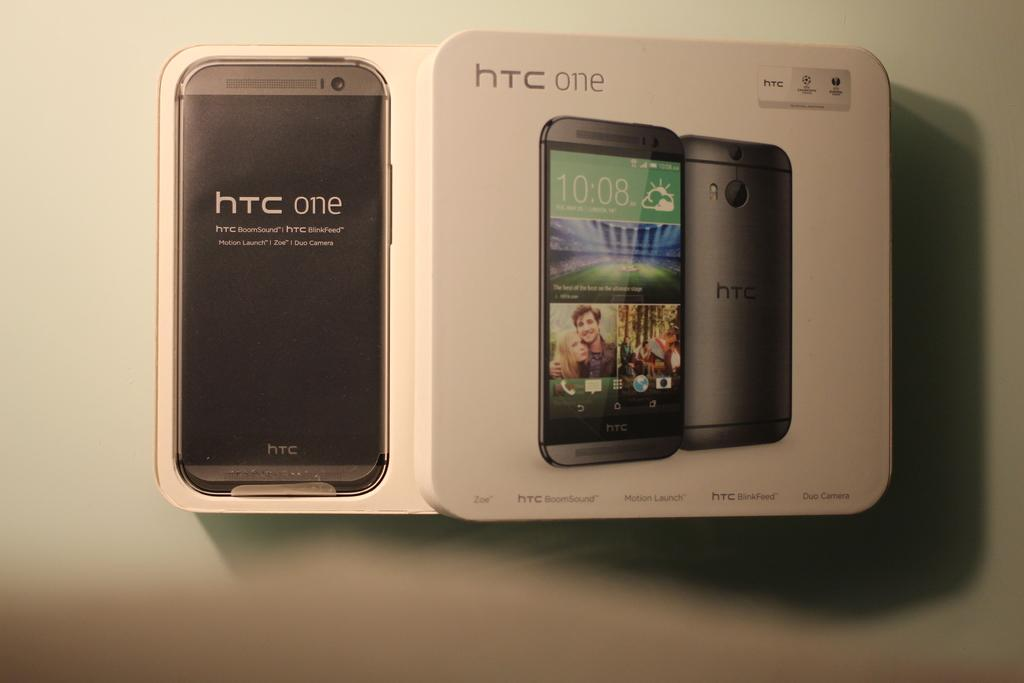<image>
Render a clear and concise summary of the photo. A smartphone called a htc one is new in it's box. 